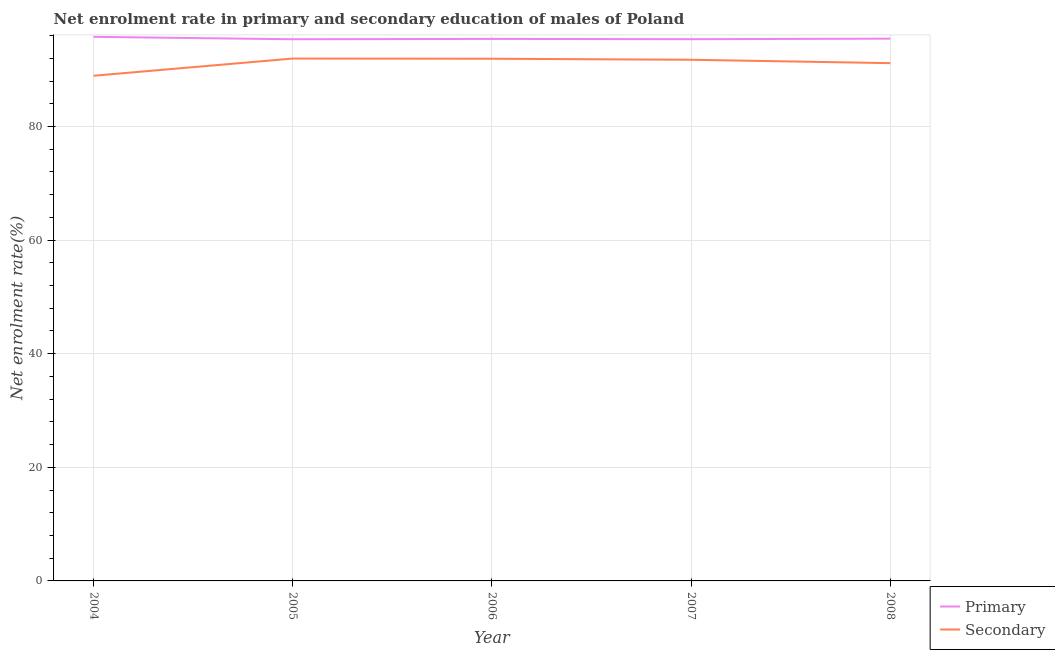How many different coloured lines are there?
Offer a very short reply. 2. Does the line corresponding to enrollment rate in primary education intersect with the line corresponding to enrollment rate in secondary education?
Offer a very short reply. No. Is the number of lines equal to the number of legend labels?
Your answer should be very brief. Yes. What is the enrollment rate in secondary education in 2006?
Give a very brief answer. 91.92. Across all years, what is the maximum enrollment rate in secondary education?
Keep it short and to the point. 91.96. Across all years, what is the minimum enrollment rate in primary education?
Keep it short and to the point. 95.35. In which year was the enrollment rate in secondary education maximum?
Offer a very short reply. 2005. What is the total enrollment rate in primary education in the graph?
Give a very brief answer. 477.37. What is the difference between the enrollment rate in primary education in 2007 and that in 2008?
Provide a short and direct response. -0.1. What is the difference between the enrollment rate in primary education in 2004 and the enrollment rate in secondary education in 2008?
Keep it short and to the point. 4.63. What is the average enrollment rate in primary education per year?
Provide a succinct answer. 95.47. In the year 2006, what is the difference between the enrollment rate in primary education and enrollment rate in secondary education?
Make the answer very short. 3.49. In how many years, is the enrollment rate in primary education greater than 92 %?
Your answer should be very brief. 5. What is the ratio of the enrollment rate in primary education in 2007 to that in 2008?
Keep it short and to the point. 1. What is the difference between the highest and the second highest enrollment rate in primary education?
Your answer should be very brief. 0.32. What is the difference between the highest and the lowest enrollment rate in secondary education?
Your response must be concise. 3.03. Does the enrollment rate in primary education monotonically increase over the years?
Provide a succinct answer. No. Is the enrollment rate in secondary education strictly less than the enrollment rate in primary education over the years?
Ensure brevity in your answer.  Yes. How many lines are there?
Provide a short and direct response. 2. How many years are there in the graph?
Make the answer very short. 5. Does the graph contain any zero values?
Keep it short and to the point. No. Does the graph contain grids?
Provide a short and direct response. Yes. Where does the legend appear in the graph?
Provide a short and direct response. Bottom right. How many legend labels are there?
Make the answer very short. 2. What is the title of the graph?
Provide a succinct answer. Net enrolment rate in primary and secondary education of males of Poland. What is the label or title of the X-axis?
Keep it short and to the point. Year. What is the label or title of the Y-axis?
Keep it short and to the point. Net enrolment rate(%). What is the Net enrolment rate(%) of Primary in 2004?
Your answer should be very brief. 95.78. What is the Net enrolment rate(%) of Secondary in 2004?
Offer a terse response. 88.93. What is the Net enrolment rate(%) of Primary in 2005?
Your answer should be compact. 95.35. What is the Net enrolment rate(%) of Secondary in 2005?
Provide a short and direct response. 91.96. What is the Net enrolment rate(%) of Primary in 2006?
Provide a succinct answer. 95.41. What is the Net enrolment rate(%) of Secondary in 2006?
Your answer should be very brief. 91.92. What is the Net enrolment rate(%) in Primary in 2007?
Ensure brevity in your answer.  95.36. What is the Net enrolment rate(%) in Secondary in 2007?
Provide a succinct answer. 91.74. What is the Net enrolment rate(%) in Primary in 2008?
Your answer should be very brief. 95.46. What is the Net enrolment rate(%) of Secondary in 2008?
Your answer should be very brief. 91.15. Across all years, what is the maximum Net enrolment rate(%) in Primary?
Make the answer very short. 95.78. Across all years, what is the maximum Net enrolment rate(%) in Secondary?
Offer a terse response. 91.96. Across all years, what is the minimum Net enrolment rate(%) in Primary?
Ensure brevity in your answer.  95.35. Across all years, what is the minimum Net enrolment rate(%) in Secondary?
Offer a very short reply. 88.93. What is the total Net enrolment rate(%) in Primary in the graph?
Offer a terse response. 477.37. What is the total Net enrolment rate(%) in Secondary in the graph?
Provide a succinct answer. 455.7. What is the difference between the Net enrolment rate(%) of Primary in 2004 and that in 2005?
Offer a very short reply. 0.43. What is the difference between the Net enrolment rate(%) in Secondary in 2004 and that in 2005?
Keep it short and to the point. -3.03. What is the difference between the Net enrolment rate(%) in Primary in 2004 and that in 2006?
Offer a very short reply. 0.37. What is the difference between the Net enrolment rate(%) of Secondary in 2004 and that in 2006?
Your answer should be compact. -2.99. What is the difference between the Net enrolment rate(%) in Primary in 2004 and that in 2007?
Offer a very short reply. 0.42. What is the difference between the Net enrolment rate(%) in Secondary in 2004 and that in 2007?
Make the answer very short. -2.81. What is the difference between the Net enrolment rate(%) in Primary in 2004 and that in 2008?
Your answer should be very brief. 0.32. What is the difference between the Net enrolment rate(%) of Secondary in 2004 and that in 2008?
Keep it short and to the point. -2.22. What is the difference between the Net enrolment rate(%) of Primary in 2005 and that in 2006?
Offer a very short reply. -0.06. What is the difference between the Net enrolment rate(%) in Secondary in 2005 and that in 2006?
Provide a succinct answer. 0.03. What is the difference between the Net enrolment rate(%) in Primary in 2005 and that in 2007?
Keep it short and to the point. -0.01. What is the difference between the Net enrolment rate(%) in Secondary in 2005 and that in 2007?
Offer a very short reply. 0.21. What is the difference between the Net enrolment rate(%) in Primary in 2005 and that in 2008?
Provide a short and direct response. -0.11. What is the difference between the Net enrolment rate(%) in Secondary in 2005 and that in 2008?
Your response must be concise. 0.81. What is the difference between the Net enrolment rate(%) in Primary in 2006 and that in 2007?
Offer a terse response. 0.05. What is the difference between the Net enrolment rate(%) of Secondary in 2006 and that in 2007?
Provide a short and direct response. 0.18. What is the difference between the Net enrolment rate(%) of Primary in 2006 and that in 2008?
Your answer should be very brief. -0.05. What is the difference between the Net enrolment rate(%) in Secondary in 2006 and that in 2008?
Your answer should be compact. 0.77. What is the difference between the Net enrolment rate(%) in Primary in 2007 and that in 2008?
Ensure brevity in your answer.  -0.1. What is the difference between the Net enrolment rate(%) of Secondary in 2007 and that in 2008?
Your response must be concise. 0.59. What is the difference between the Net enrolment rate(%) of Primary in 2004 and the Net enrolment rate(%) of Secondary in 2005?
Your answer should be very brief. 3.83. What is the difference between the Net enrolment rate(%) in Primary in 2004 and the Net enrolment rate(%) in Secondary in 2006?
Ensure brevity in your answer.  3.86. What is the difference between the Net enrolment rate(%) in Primary in 2004 and the Net enrolment rate(%) in Secondary in 2007?
Your response must be concise. 4.04. What is the difference between the Net enrolment rate(%) in Primary in 2004 and the Net enrolment rate(%) in Secondary in 2008?
Offer a very short reply. 4.63. What is the difference between the Net enrolment rate(%) of Primary in 2005 and the Net enrolment rate(%) of Secondary in 2006?
Your answer should be very brief. 3.43. What is the difference between the Net enrolment rate(%) of Primary in 2005 and the Net enrolment rate(%) of Secondary in 2007?
Provide a succinct answer. 3.61. What is the difference between the Net enrolment rate(%) of Primary in 2005 and the Net enrolment rate(%) of Secondary in 2008?
Provide a short and direct response. 4.2. What is the difference between the Net enrolment rate(%) in Primary in 2006 and the Net enrolment rate(%) in Secondary in 2007?
Give a very brief answer. 3.67. What is the difference between the Net enrolment rate(%) of Primary in 2006 and the Net enrolment rate(%) of Secondary in 2008?
Offer a terse response. 4.26. What is the difference between the Net enrolment rate(%) in Primary in 2007 and the Net enrolment rate(%) in Secondary in 2008?
Provide a short and direct response. 4.21. What is the average Net enrolment rate(%) of Primary per year?
Your answer should be compact. 95.47. What is the average Net enrolment rate(%) in Secondary per year?
Provide a succinct answer. 91.14. In the year 2004, what is the difference between the Net enrolment rate(%) of Primary and Net enrolment rate(%) of Secondary?
Make the answer very short. 6.85. In the year 2005, what is the difference between the Net enrolment rate(%) in Primary and Net enrolment rate(%) in Secondary?
Your response must be concise. 3.4. In the year 2006, what is the difference between the Net enrolment rate(%) of Primary and Net enrolment rate(%) of Secondary?
Your response must be concise. 3.49. In the year 2007, what is the difference between the Net enrolment rate(%) in Primary and Net enrolment rate(%) in Secondary?
Give a very brief answer. 3.62. In the year 2008, what is the difference between the Net enrolment rate(%) of Primary and Net enrolment rate(%) of Secondary?
Provide a succinct answer. 4.31. What is the ratio of the Net enrolment rate(%) of Primary in 2004 to that in 2005?
Your answer should be very brief. 1. What is the ratio of the Net enrolment rate(%) of Secondary in 2004 to that in 2005?
Your answer should be very brief. 0.97. What is the ratio of the Net enrolment rate(%) of Secondary in 2004 to that in 2006?
Your response must be concise. 0.97. What is the ratio of the Net enrolment rate(%) in Secondary in 2004 to that in 2007?
Your answer should be very brief. 0.97. What is the ratio of the Net enrolment rate(%) in Primary in 2004 to that in 2008?
Provide a succinct answer. 1. What is the ratio of the Net enrolment rate(%) of Secondary in 2004 to that in 2008?
Offer a very short reply. 0.98. What is the ratio of the Net enrolment rate(%) of Primary in 2005 to that in 2006?
Your response must be concise. 1. What is the ratio of the Net enrolment rate(%) of Secondary in 2005 to that in 2008?
Your answer should be compact. 1.01. What is the ratio of the Net enrolment rate(%) in Primary in 2006 to that in 2007?
Offer a very short reply. 1. What is the ratio of the Net enrolment rate(%) in Primary in 2006 to that in 2008?
Ensure brevity in your answer.  1. What is the ratio of the Net enrolment rate(%) in Secondary in 2006 to that in 2008?
Provide a succinct answer. 1.01. What is the difference between the highest and the second highest Net enrolment rate(%) of Primary?
Give a very brief answer. 0.32. What is the difference between the highest and the second highest Net enrolment rate(%) in Secondary?
Offer a terse response. 0.03. What is the difference between the highest and the lowest Net enrolment rate(%) of Primary?
Give a very brief answer. 0.43. What is the difference between the highest and the lowest Net enrolment rate(%) of Secondary?
Offer a very short reply. 3.03. 